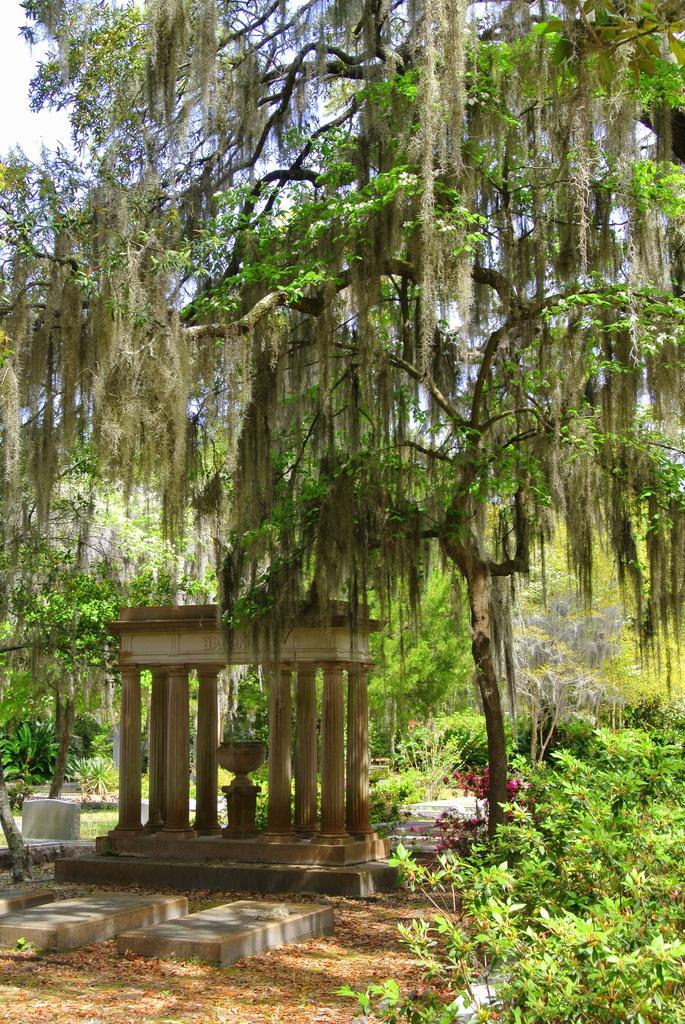Please provide a concise description of this image. In the center of the image we can see the sky, clouds, trees, plants, stones, pillars, one outdoor structure, one pot and a few other objects. 